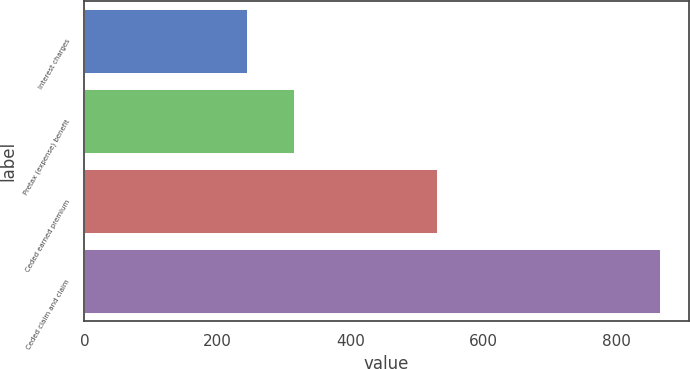Convert chart. <chart><loc_0><loc_0><loc_500><loc_500><bar_chart><fcel>Interest charges<fcel>Pretax (expense) benefit<fcel>Ceded earned premium<fcel>Ceded claim and claim<nl><fcel>245<fcel>315.8<fcel>530<fcel>865<nl></chart> 